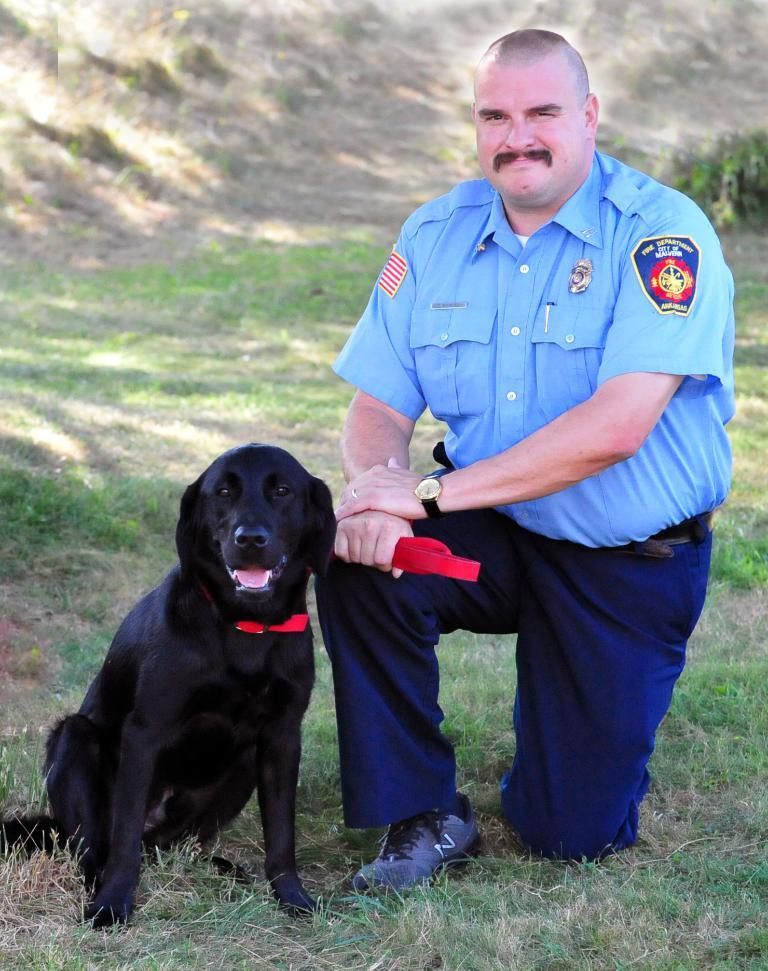What is the main subject of the image? There is a person in the image. What is the person wearing? The person is wearing a blue shirt. What is the person doing in the image? The person is crouched. What is the person holding in their right hand? The person is holding a red belt in their right hand. What is the red belt attached to? The red belt is attached to a black dog. Where is the black dog located in relation to the person? The black dog is beside the person. What is the ground covered with? The ground is covered in greenery. What type of kite is the person flying in the image? There is no kite present in the image. What team does the person belong to in the image? There is no indication of a team in the image. What type of drug is the person holding in their left hand in the image? The person is not holding any drug in their left hand, as they are holding a red belt in their right hand. 